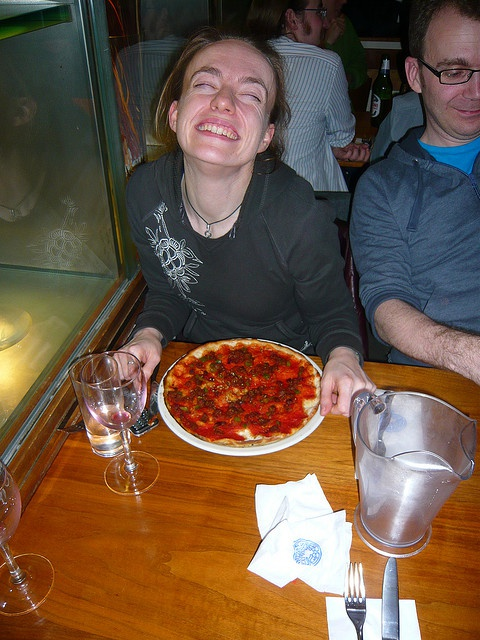Describe the objects in this image and their specific colors. I can see dining table in gray, brown, white, and maroon tones, people in gray, black, darkgray, and lightpink tones, people in gray, blue, and navy tones, cup in gray, darkgray, and lightgray tones, and people in gray and black tones in this image. 